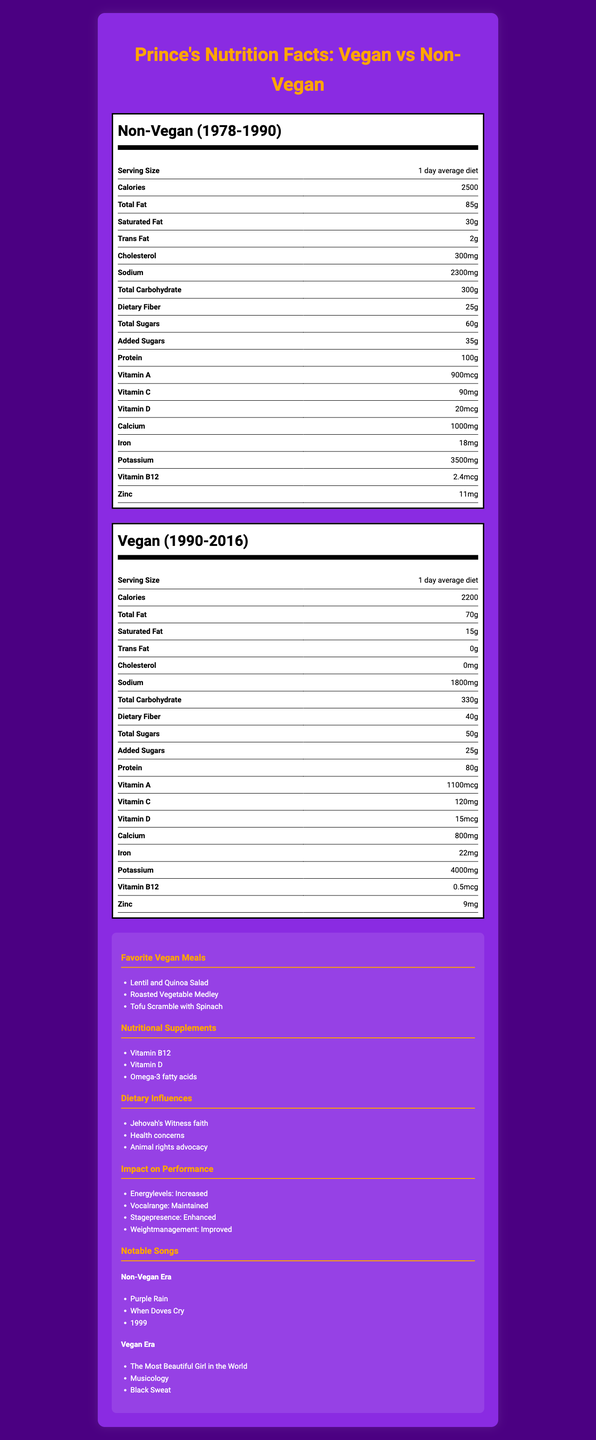how many calories were consumed on average during Prince's non-vegan period? The nutrition facts for the "Non-Vegan (1978-1990)" period show that the average daily diet included 2500 calories.
Answer: 2500 what is the difference in total fat between the vegan and non-vegan periods? The non-vegan period had 85g of total fat, while the vegan period had 70g of total fat, making a difference of 15g.
Answer: 15g which period had higher dietary fiber intake? The non-vegan period had 25g of dietary fiber, whereas the vegan period had 40g of dietary fiber.
Answer: Vegan (1990-2016) what are Prince's favorite vegan meals? The additional information section lists "Favorite Vegan Meals" which include Lentil and Quinoa Salad, Roasted Vegetable Medley, and Tofu Scramble with Spinach.
Answer: Lentil and Quinoa Salad, Roasted Vegetable Medley, Tofu Scramble with Spinach how much calcium was consumed on average during Prince's vegan period? The nutrition facts for the "Vegan (1990-2016)" period show that 800mg of calcium was consumed on average per day.
Answer: 800mg which vitamin had an increased intake during the vegan period? \
I. Vitamin A \
II. Vitamin C \
III. Vitamin D \
IV. Vitamin B12 During the vegan period, the intake of Vitamin A increased from 900mcg to 1100mcg and the intake of Vitamin C increased from 90mg to 120mg, while Vitamin D and Vitamin B12 showed a decrease.
Answer: I, II which of the following was a notable song from Prince's vegan era? \
A. Purple Rain \
B. Musicology \
C. When Doves Cry \
D. 1999 "Musicology" is listed under "Notable Songs" from the vegan era.
Answer: B did Prince's sodium intake increase during his vegan period? The sodium intake during the non-vegan period was 2300mg, compared to 1800mg during the vegan period, indicating a decrease.
Answer: No summarize the main nutritional differences between Prince's vegan and non-vegan periods. The document highlights the nutritional differences between Prince's vegan and non-vegan periods, detailing changes in various vitamins, minerals, and macronutrients. It also includes supplementary information about his favorite vegan meals, nutritional supplements, dietary influences, the impact on performance, and notable songs from each period.
Answer: During Prince's vegan period, his diet had fewer calories, total fat, saturated fat, trans fat, cholesterol, sodium, total sugars, added sugars, protein, vitamin D, calcium, vitamin B12, and zinc. Conversely, it had more dietary fiber, total carbohydrate, vitamin A, vitamin C, iron, and potassium. Additionally, there were specific favorite vegan meals and nutritional supplements that he included in his diet. what factors influenced Prince's decision to switch to a vegan diet? The "Dietary Influences" section lists these three factors as influences for Prince's switch to a vegan diet.
Answer: Jehovah's Witness faith, Health concerns, Animal rights advocacy how much protein did Prince consume on average during his non-vegan period? The "Non-Vegan (1978-1990)" nutrition facts show that Prince's average daily protein consumption was 100g.
Answer: 100g what was Prince's weight management outcome after switching to a vegan diet? The "Impact on Performance" section states that Prince's weight management improved after switching to a vegan diet.
Answer: Improved how many grams of dietary fiber did Prince consume on average per day in his non-vegan period? The nutrition label for the non-vegan period lists 25g of dietary fiber per day.
Answer: 25g did Prince's total carbohydrate intake decrease during his vegan period? The total carbohydrate intake increased from 300g to 330g during the vegan period.
Answer: No list the notable songs from Prince's non-vegan era. The "Notable Songs" section under the non-vegan era lists these songs.
Answer: Purple Rain, When Doves Cry, 1999 what were the exact amounts of increased vitamins during Prince's vegan period? During Prince's vegan period, the intake of Vitamin A increased by 200mcg and Vitamin C increased by 30mg.
Answer: Vitamin A: +200mcg, Vitamin C: +30mg how did Prince's stage presence change after switching to a vegan diet? The "Impact on Performance" section notes that Prince's stage presence was enhanced after adopting a vegan diet.
Answer: Enhanced what are the correct daily values for all the nutrients? The document only provides the average daily intake values for the nutrients during the vegan and non-vegan periods but does not provide the recommended daily values (RDV) for comparison.
Answer: Cannot be determined 